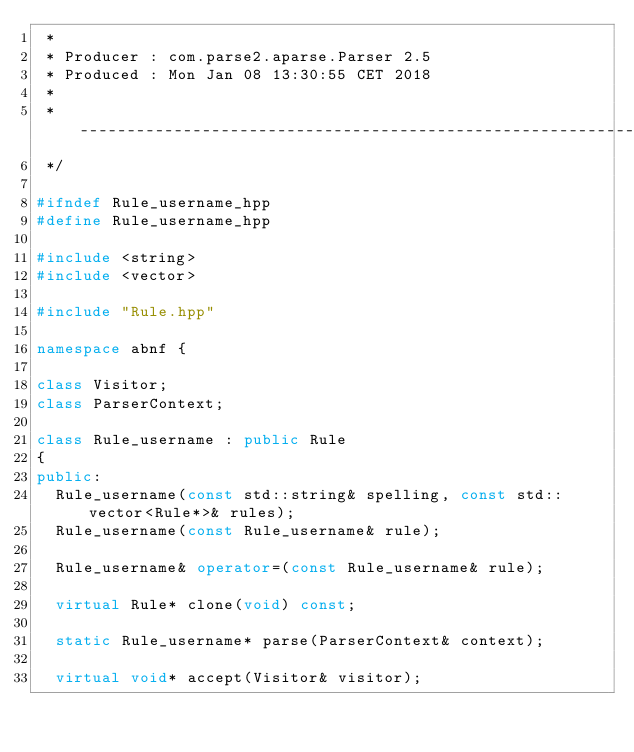Convert code to text. <code><loc_0><loc_0><loc_500><loc_500><_C++_> *
 * Producer : com.parse2.aparse.Parser 2.5
 * Produced : Mon Jan 08 13:30:55 CET 2018
 *
 * -----------------------------------------------------------------------------
 */

#ifndef Rule_username_hpp
#define Rule_username_hpp

#include <string>
#include <vector>

#include "Rule.hpp"

namespace abnf {

class Visitor;
class ParserContext;

class Rule_username : public Rule
{
public:
  Rule_username(const std::string& spelling, const std::vector<Rule*>& rules);
  Rule_username(const Rule_username& rule);

  Rule_username& operator=(const Rule_username& rule);

  virtual Rule* clone(void) const;

  static Rule_username* parse(ParserContext& context);

  virtual void* accept(Visitor& visitor);</code> 